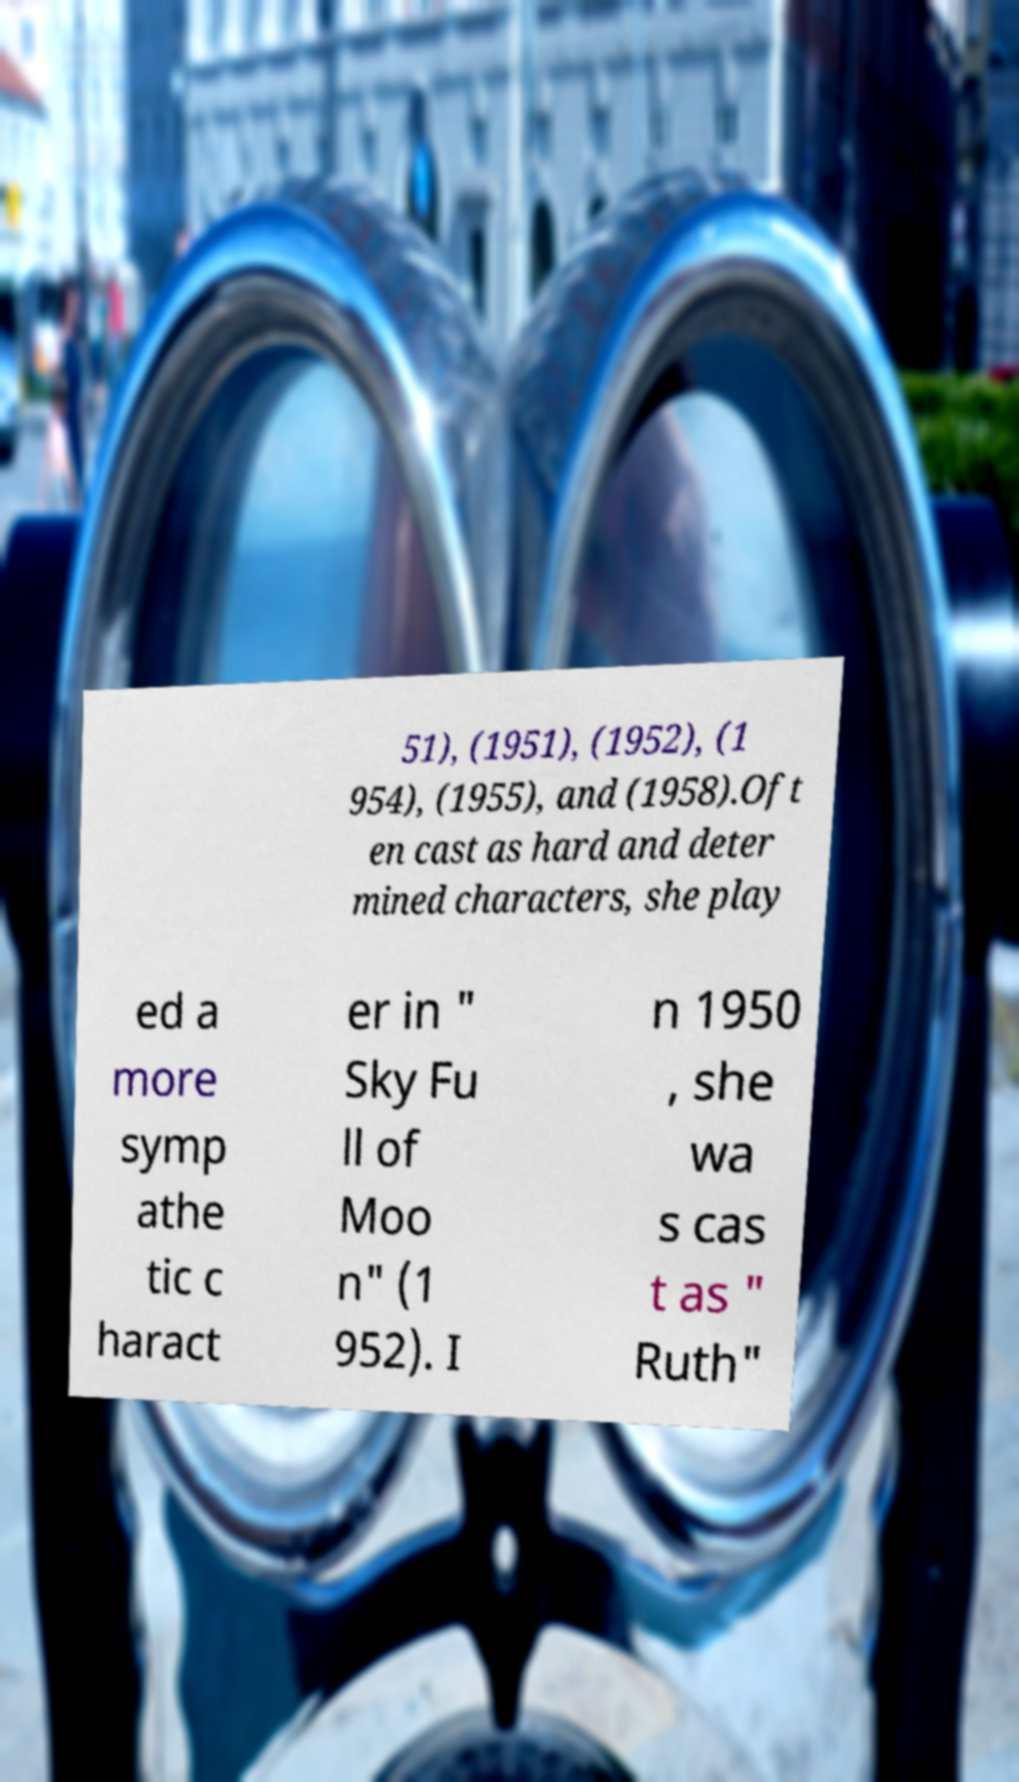I need the written content from this picture converted into text. Can you do that? 51), (1951), (1952), (1 954), (1955), and (1958).Oft en cast as hard and deter mined characters, she play ed a more symp athe tic c haract er in " Sky Fu ll of Moo n" (1 952). I n 1950 , she wa s cas t as " Ruth" 